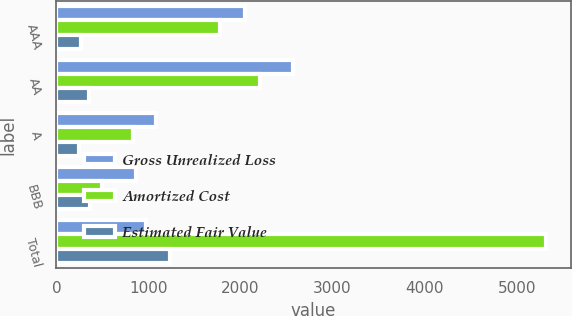<chart> <loc_0><loc_0><loc_500><loc_500><stacked_bar_chart><ecel><fcel>AAA<fcel>AA<fcel>A<fcel>BBB<fcel>Total<nl><fcel>Gross Unrealized Loss<fcel>2044<fcel>2566<fcel>1080<fcel>862<fcel>971<nl><fcel>Amortized Cost<fcel>1780<fcel>2213<fcel>831<fcel>496<fcel>5320<nl><fcel>Estimated Fair Value<fcel>264<fcel>353<fcel>249<fcel>366<fcel>1232<nl></chart> 